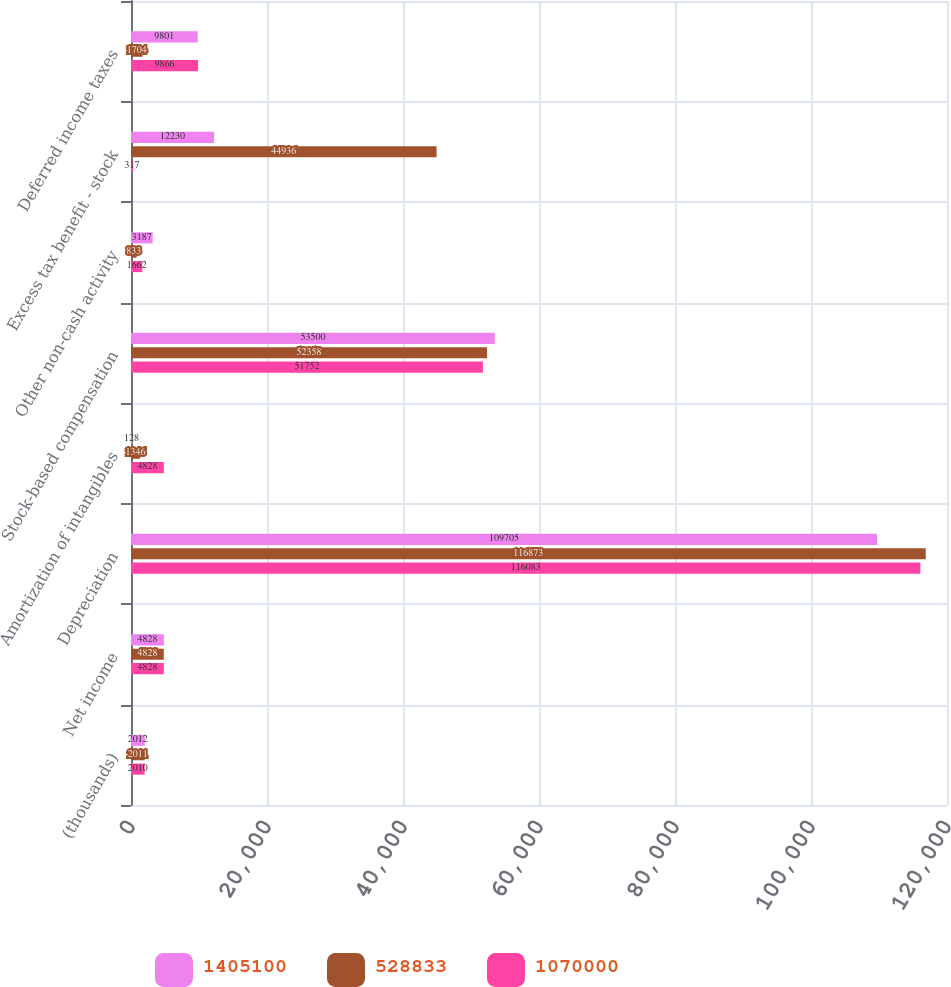<chart> <loc_0><loc_0><loc_500><loc_500><stacked_bar_chart><ecel><fcel>(thousands)<fcel>Net income<fcel>Depreciation<fcel>Amortization of intangibles<fcel>Stock-based compensation<fcel>Other non-cash activity<fcel>Excess tax benefit - stock<fcel>Deferred income taxes<nl><fcel>1.4051e+06<fcel>2012<fcel>4828<fcel>109705<fcel>128<fcel>53500<fcel>3187<fcel>12230<fcel>9801<nl><fcel>528833<fcel>2011<fcel>4828<fcel>116873<fcel>1346<fcel>52358<fcel>833<fcel>44936<fcel>1704<nl><fcel>1.07e+06<fcel>2010<fcel>4828<fcel>116083<fcel>4828<fcel>51752<fcel>1662<fcel>317<fcel>9866<nl></chart> 